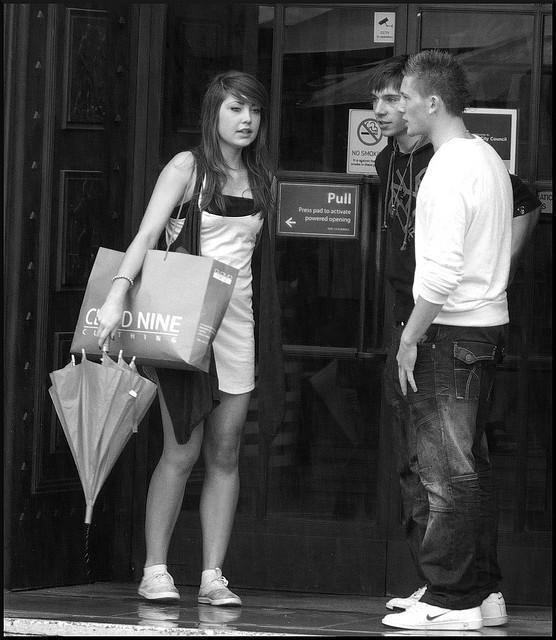How many people are there?
Give a very brief answer. 3. 